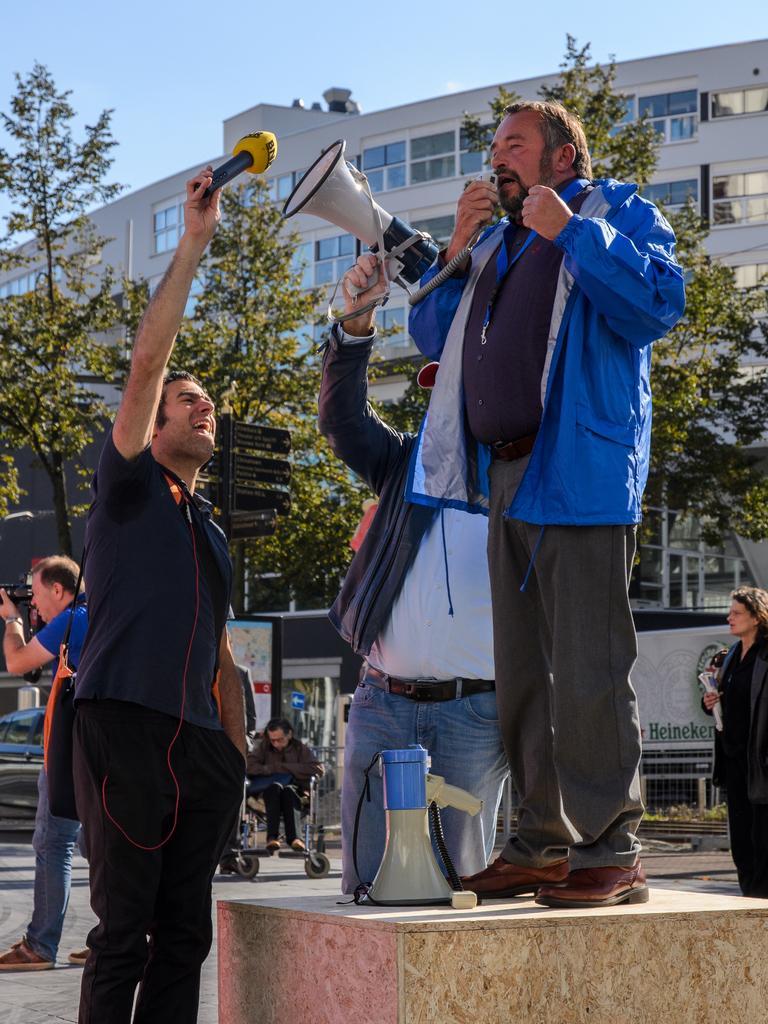In one or two sentences, can you explain what this image depicts? Here we can see few persons. One person is holding a mike and another person is holding a speaker. There are trees and boards. In the background we can see a building and sky. 